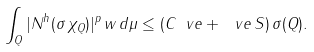<formula> <loc_0><loc_0><loc_500><loc_500>\int _ { Q } | N ^ { h } ( \sigma \, \chi _ { Q } ) | ^ { p } \, w \, d \mu \leq ( C _ { \ } v e + \ v e \, S ) \, \sigma ( Q ) .</formula> 